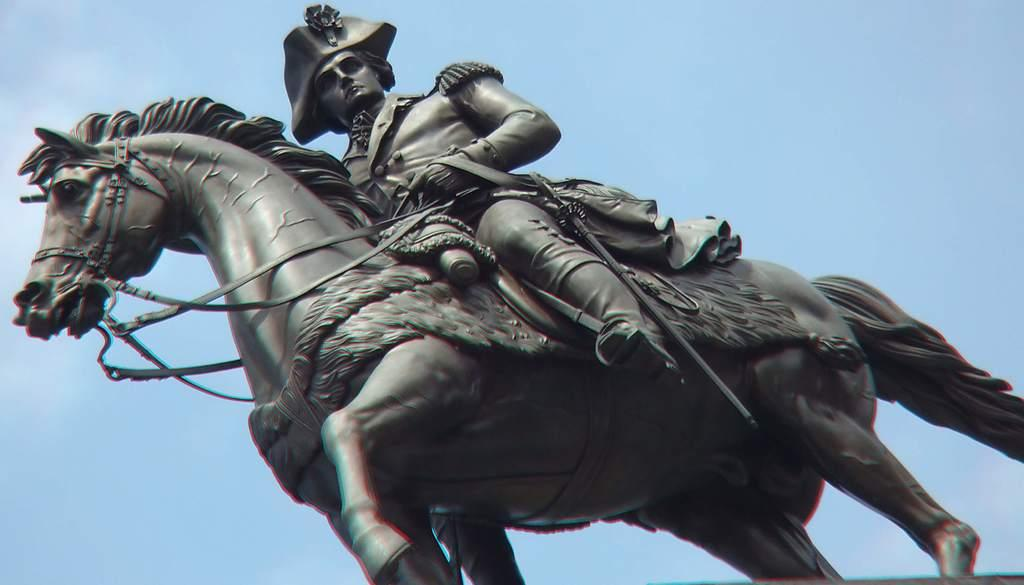What is the main subject in the center of the image? There is a statue in the center of the image. What can be seen in the background of the image? There is sky visible in the background of the image. What advice does the statue give to the people in the image? The statue does not give advice in the image, as it is a non-living object and cannot speak or provide advice. 